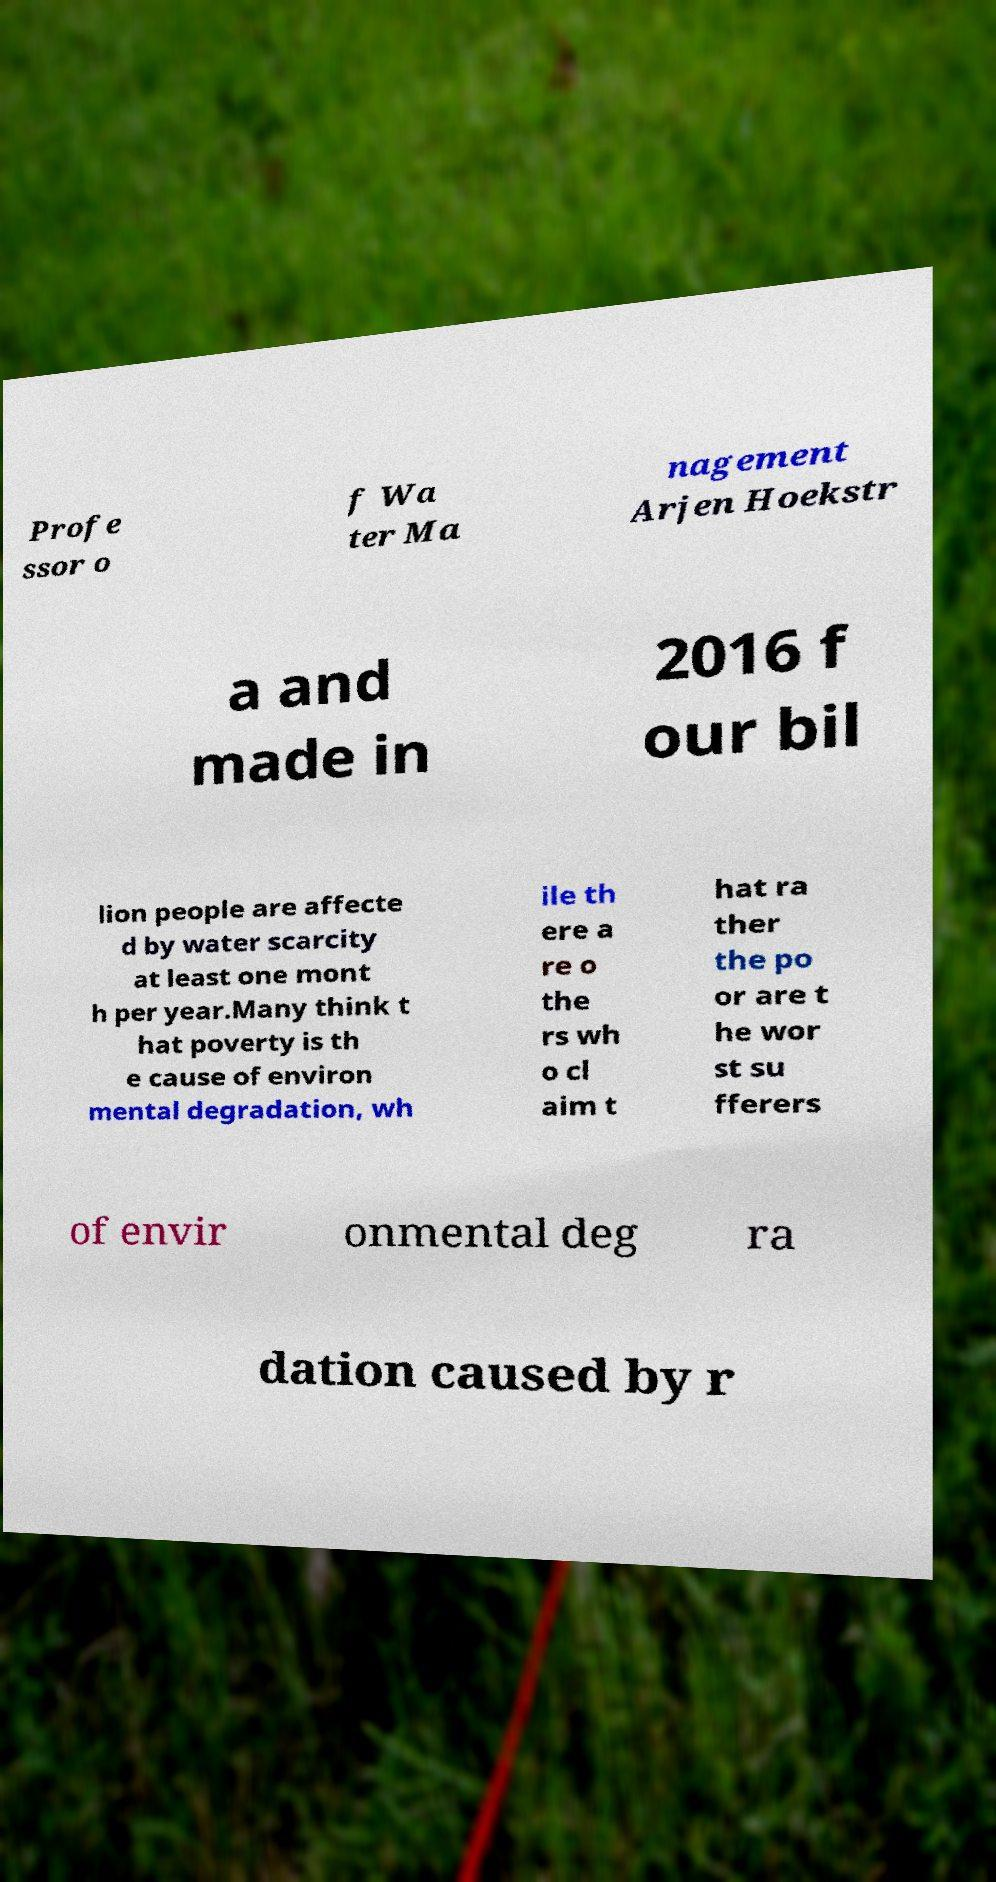Can you accurately transcribe the text from the provided image for me? Profe ssor o f Wa ter Ma nagement Arjen Hoekstr a and made in 2016 f our bil lion people are affecte d by water scarcity at least one mont h per year.Many think t hat poverty is th e cause of environ mental degradation, wh ile th ere a re o the rs wh o cl aim t hat ra ther the po or are t he wor st su fferers of envir onmental deg ra dation caused by r 